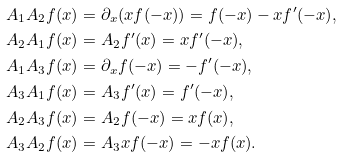Convert formula to latex. <formula><loc_0><loc_0><loc_500><loc_500>A _ { 1 } A _ { 2 } f ( x ) & = \partial _ { x } ( x f ( - x ) ) = f ( - x ) - x f ^ { \prime } ( - x ) , \\ A _ { 2 } A _ { 1 } f ( x ) & = A _ { 2 } f ^ { \prime } ( x ) = x f ^ { \prime } ( - x ) , \\ A _ { 1 } A _ { 3 } f ( x ) & = \partial _ { x } f ( - x ) = - f ^ { \prime } ( - x ) , \\ A _ { 3 } A _ { 1 } f ( x ) & = A _ { 3 } f ^ { \prime } ( x ) = f ^ { \prime } ( - x ) , \\ A _ { 2 } A _ { 3 } f ( x ) & = A _ { 2 } f ( - x ) = x f ( x ) , \\ A _ { 3 } A _ { 2 } f ( x ) & = A _ { 3 } x f ( - x ) = - x f ( x ) .</formula> 